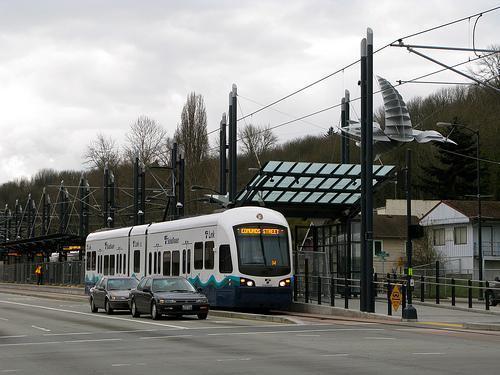How many buses are there?
Give a very brief answer. 1. 